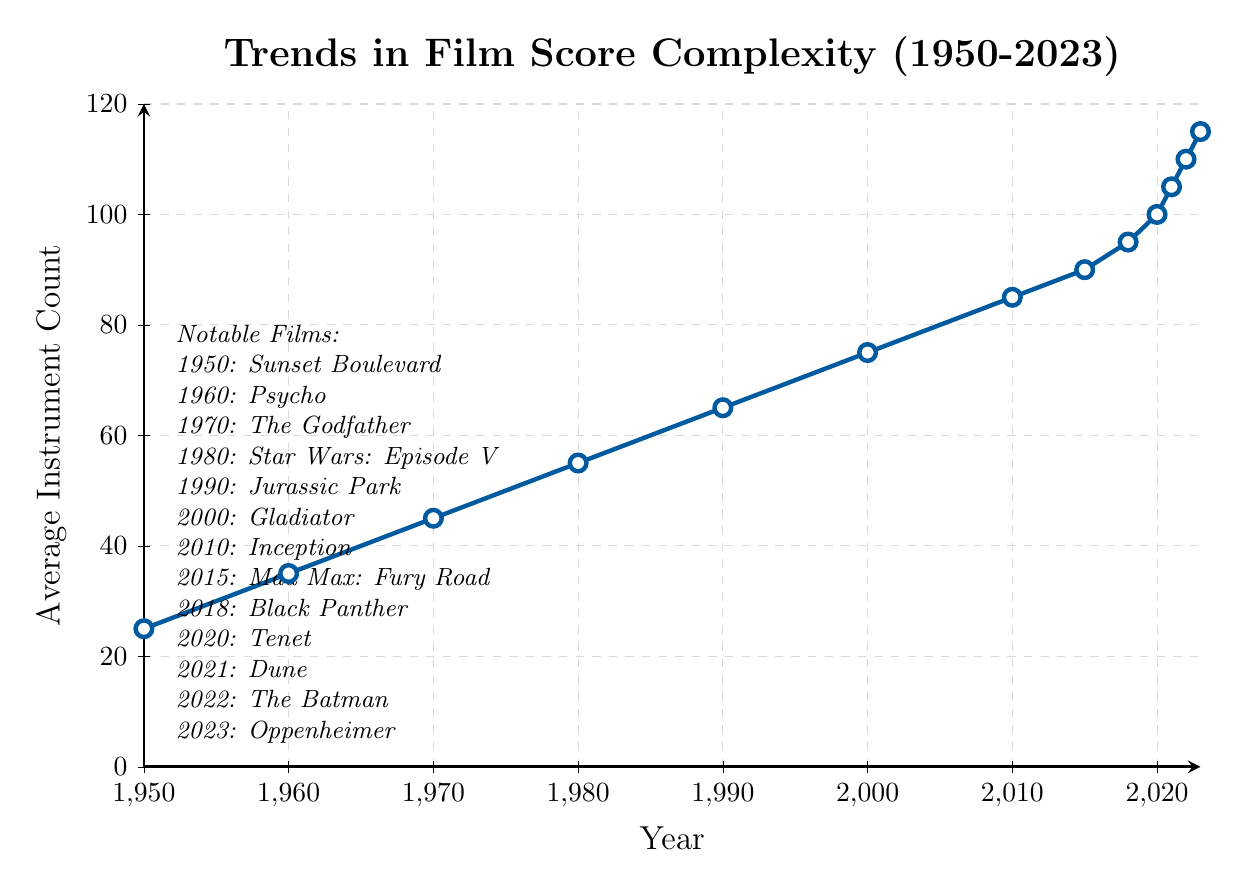What is the general trend of the average instrument count in film scores from 1950 to 2023? The trend shows a consistent increase in the average instrument count in film scores over the years, moving from 25 in 1950 to 115 in 2023.
Answer: Increasing Which year marked the sharpest increase in the average instrument count from the previous year? The largest increase in average instrument count between consecutive years is from 2018 (95) to 2020 (100), indicating an increase of 5 instruments.
Answer: 2020 Calculate the average instrument count from 1950 to 2023. Add all the values of the average instrument count and divide by the number of years: (25 + 35 + 45 + 55 + 65 + 75 + 85 + 90 + 95 + 100 + 105 + 110 + 115) / 13 = 70
Answer: 70 How does the instrument count in 1980 (Star Wars: Episode V - The Empire Strikes Back) compare to that in 2000 (Gladiator)? The instrument count in 1980 is 55, whereas in 2000 it is 75. Thus, the difference is 75 - 55 = 20, indicating an increase.
Answer: 20 increase What is the range of the average instrument count from 1950 to 2023? The range is calculated by subtracting the smallest value (25 in 1950) from the largest value (115 in 2023): 115 - 25 = 90
Answer: 90 Identify the decade with the greatest growth in average instrument count. Comparing the increase across decades shows the greatest growth from 2000 (75) to 2010 (85), an increase of 10 instruments. Other decades have smaller increases.
Answer: 2000-2010 Which notable film has the lowest average instrument count in its year? Sunset Boulevard in 1950 has the lowest average instrument count of 25.
Answer: Sunset Boulevard (1950) Between 2010 and 2023, in which year did the average instrument count reach 100? The instrument count reached 100 in 2020.
Answer: 2020 Determine the overall increase in average instrument count from the 1950s to the 2020s. For the 1950s (1950), the count is 25, and for the 2020s (2020-2023), the average is (100+105+110+115)/4 = 107.5. The increase is 107.5 - 25 = 82.5.
Answer: 82.5 What visual attribute indicates the trend in complexity, and how is it visually represented? The trend in complexity is indicated by the upward slope of the line, with points marked by colored circles getting higher over time. The line's color and each year's marker visually represent instrument count.
Answer: Upward slope with increasing marker height 